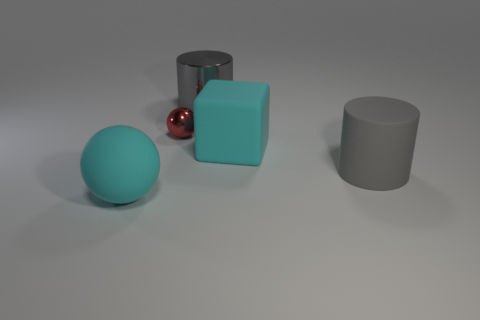Can you describe the lighting in this scene? The lighting in the scene is soft and diffused, coming from what seems to be an overhead source. It casts gentle shadows on the ground from the objects, indicating that the light source is not overly intense, simulating an indoor ambience. 